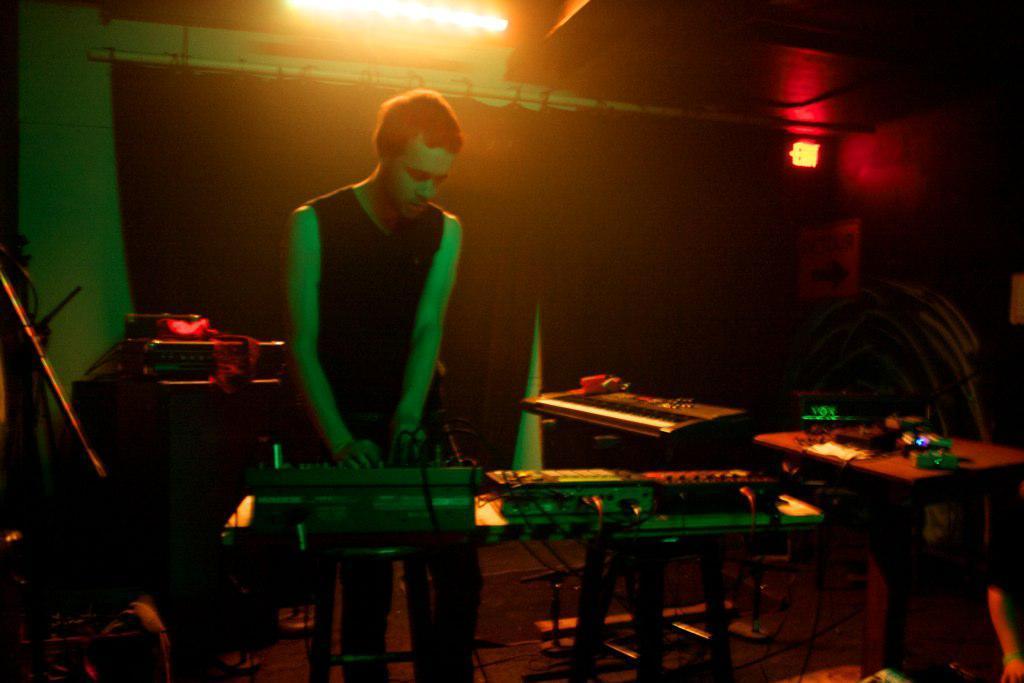Can you describe this image briefly? In this image I can see a person wearing black color dress is standing and holding wires of a equipment. I can see a piano, a table and few objects on the table and a musical system. In the background I can see a black colored curtain, a light and the exit board. 